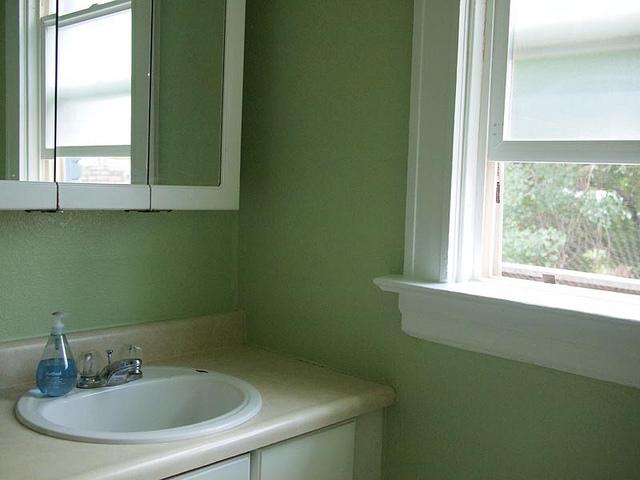Is the bathroom clean?
Keep it brief. Yes. Is there soap on this sink?
Be succinct. Yes. What kind of room is this?
Be succinct. Bathroom. 